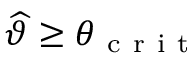<formula> <loc_0><loc_0><loc_500><loc_500>\widehat { \vartheta } \geq \theta _ { c r i t }</formula> 